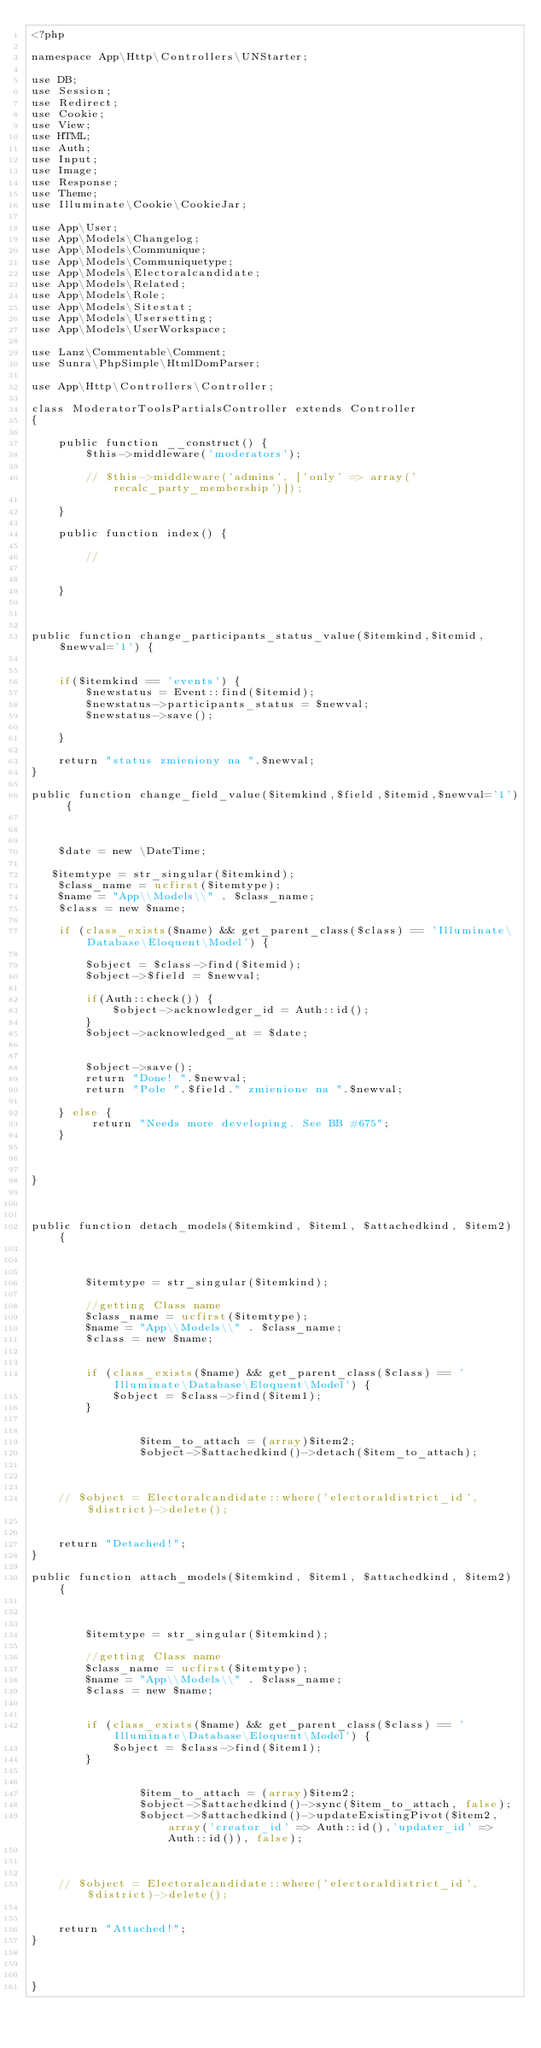<code> <loc_0><loc_0><loc_500><loc_500><_PHP_><?php

namespace App\Http\Controllers\UNStarter;

use DB;
use Session;
use Redirect;
use Cookie;
use View;
use HTML;
use Auth;
use Input;
use Image;
use Response;
use Theme;
use Illuminate\Cookie\CookieJar;

use App\User;
use App\Models\Changelog;
use App\Models\Communique;
use App\Models\Communiquetype;
use App\Models\Electoralcandidate;
use App\Models\Related;
use App\Models\Role;
use App\Models\Sitestat;
use App\Models\Usersetting;
use App\Models\UserWorkspace;

use Lanz\Commentable\Comment;
use Sunra\PhpSimple\HtmlDomParser;

use App\Http\Controllers\Controller;

class ModeratorToolsPartialsController extends Controller
{

    public function __construct() {
        $this->middleware('moderators');

        // $this->middleware('admins', ['only' => array('recalc_party_membership')]);

    }

    public function index() {

        //


    }



public function change_participants_status_value($itemkind,$itemid,$newval='1') {


    if($itemkind == 'events') {
        $newstatus = Event::find($itemid);
        $newstatus->participants_status = $newval;
        $newstatus->save();

    }

    return "status zmieniony na ".$newval;
}

public function change_field_value($itemkind,$field,$itemid,$newval='1') {



    $date = new \DateTime;

   $itemtype = str_singular($itemkind);
    $class_name = ucfirst($itemtype);
    $name = "App\\Models\\" . $class_name;
    $class = new $name;

    if (class_exists($name) && get_parent_class($class) == 'Illuminate\Database\Eloquent\Model') {

        $object = $class->find($itemid);
        $object->$field = $newval;

        if(Auth::check()) {
            $object->acknowledger_id = Auth::id();
        }
        $object->acknowledged_at = $date;


        $object->save();
        return "Done! ".$newval;
        return "Pole ".$field." zmienione na ".$newval;

    } else {
         return "Needs more developing. See BB #675";
    }



}



public function detach_models($itemkind, $item1, $attachedkind, $item2) {



        $itemtype = str_singular($itemkind);

        //getting Class name
        $class_name = ucfirst($itemtype);
        $name = "App\\Models\\" . $class_name;
        $class = new $name;

        
        if (class_exists($name) && get_parent_class($class) == 'Illuminate\Database\Eloquent\Model') {
            $object = $class->find($item1);
        }


                $item_to_attach = (array)$item2;
                $object->$attachedkind()->detach($item_to_attach);



    // $object = Electoralcandidate::where('electoraldistrict_id', $district)->delete();
    

    return "Detached!";
}

public function attach_models($itemkind, $item1, $attachedkind, $item2) {



        $itemtype = str_singular($itemkind);

        //getting Class name
        $class_name = ucfirst($itemtype);
        $name = "App\\Models\\" . $class_name;
        $class = new $name;

        
        if (class_exists($name) && get_parent_class($class) == 'Illuminate\Database\Eloquent\Model') {
            $object = $class->find($item1);
        }


                $item_to_attach = (array)$item2;
                $object->$attachedkind()->sync($item_to_attach, false);
                $object->$attachedkind()->updateExistingPivot($item2, array('creator_id' => Auth::id(),'updater_id' => Auth::id()), false);



    // $object = Electoralcandidate::where('electoraldistrict_id', $district)->delete();
    

    return "Attached!";
}



}
</code> 